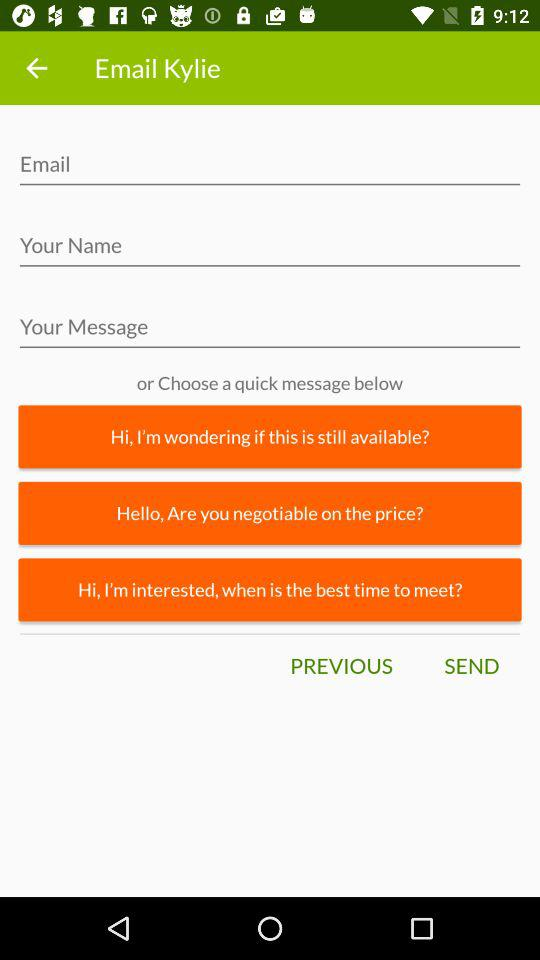How many quick message options are there?
Answer the question using a single word or phrase. 3 